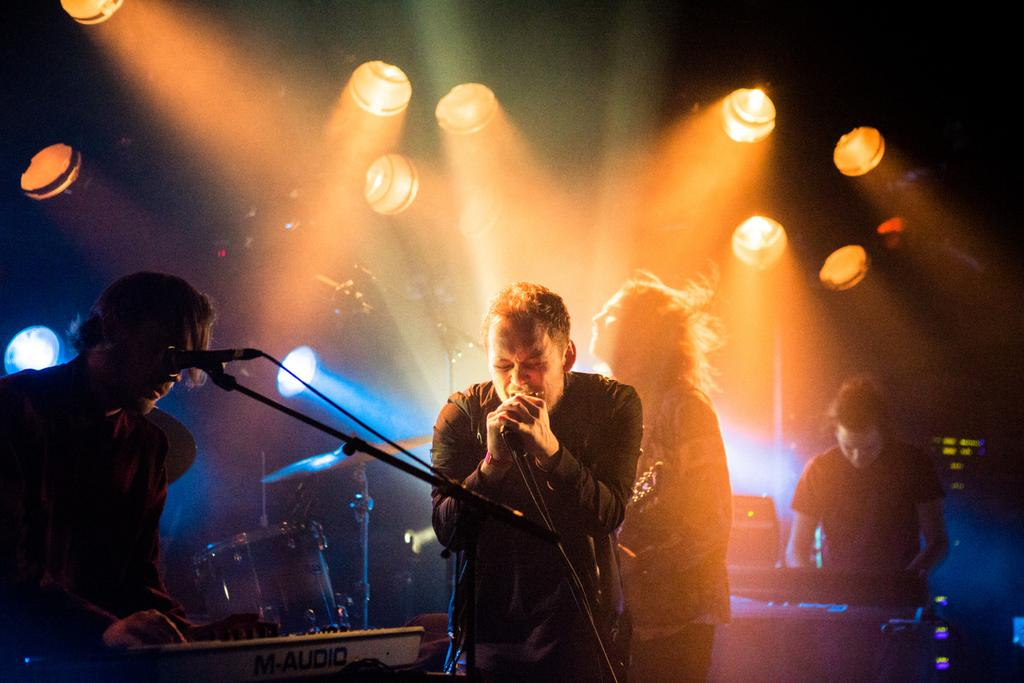How many people are present in the image? There are four people in the image. What are two of the people doing in the image? Two people are standing in front of a mic. What are the other two people doing in the image? The other two people are playing musical instruments. What can be seen in the background of the image? There are lights visible in the background of the image. What type of scent can be detected from the image? There is no scent present in the image, as it is a visual medium. What type of footwear is visible on the people in the image? There is no information about footwear in the image, as the focus is on the people's actions and the presence of lights in the background. 